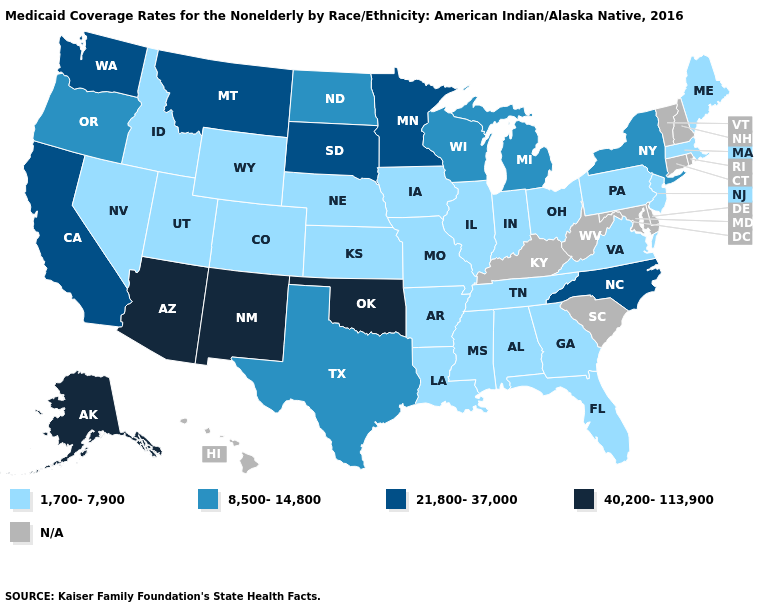Name the states that have a value in the range N/A?
Keep it brief. Connecticut, Delaware, Hawaii, Kentucky, Maryland, New Hampshire, Rhode Island, South Carolina, Vermont, West Virginia. What is the value of Oregon?
Be succinct. 8,500-14,800. Does New York have the highest value in the Northeast?
Write a very short answer. Yes. Name the states that have a value in the range 8,500-14,800?
Give a very brief answer. Michigan, New York, North Dakota, Oregon, Texas, Wisconsin. Name the states that have a value in the range 21,800-37,000?
Keep it brief. California, Minnesota, Montana, North Carolina, South Dakota, Washington. What is the value of Colorado?
Give a very brief answer. 1,700-7,900. Name the states that have a value in the range 1,700-7,900?
Write a very short answer. Alabama, Arkansas, Colorado, Florida, Georgia, Idaho, Illinois, Indiana, Iowa, Kansas, Louisiana, Maine, Massachusetts, Mississippi, Missouri, Nebraska, Nevada, New Jersey, Ohio, Pennsylvania, Tennessee, Utah, Virginia, Wyoming. Among the states that border Wyoming , which have the highest value?
Be succinct. Montana, South Dakota. Does Maine have the highest value in the Northeast?
Concise answer only. No. What is the lowest value in states that border Minnesota?
Quick response, please. 1,700-7,900. What is the value of South Carolina?
Keep it brief. N/A. Does the first symbol in the legend represent the smallest category?
Keep it brief. Yes. Name the states that have a value in the range 8,500-14,800?
Answer briefly. Michigan, New York, North Dakota, Oregon, Texas, Wisconsin. Name the states that have a value in the range N/A?
Quick response, please. Connecticut, Delaware, Hawaii, Kentucky, Maryland, New Hampshire, Rhode Island, South Carolina, Vermont, West Virginia. What is the value of Kansas?
Write a very short answer. 1,700-7,900. 